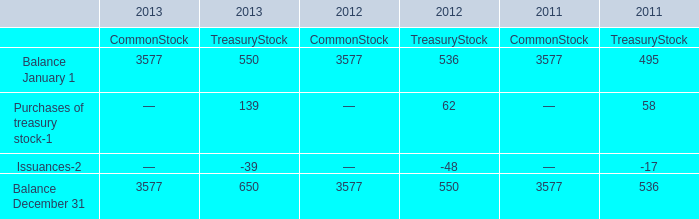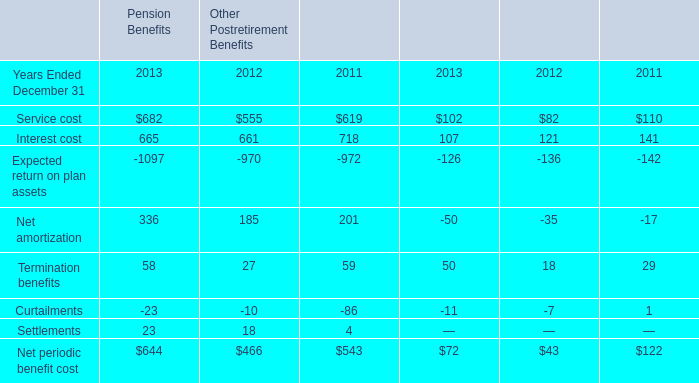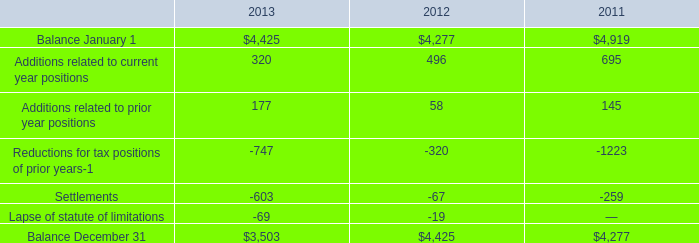based on the reconciliation what was the percent of the change in the unrecognized tax benefits from 2011 to 2012 
Computations: ((4425 - 4277) / 4277)
Answer: 0.0346. 